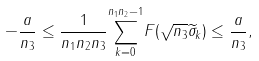<formula> <loc_0><loc_0><loc_500><loc_500>- \frac { a } { n _ { 3 } } \leq \frac { 1 } { n _ { 1 } n _ { 2 } n _ { 3 } } \overset { n _ { 1 } n _ { 2 } - 1 } { \underset { k = 0 } \sum } F ( \sqrt { n _ { 3 } } \widetilde { \sigma } _ { k } ) \leq \frac { a } { n _ { 3 } } ,</formula> 